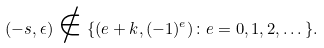Convert formula to latex. <formula><loc_0><loc_0><loc_500><loc_500>( - s , \epsilon ) \notin \{ ( e + k , ( - 1 ) ^ { e } ) \colon e = 0 , 1 , 2 , \dots \} .</formula> 